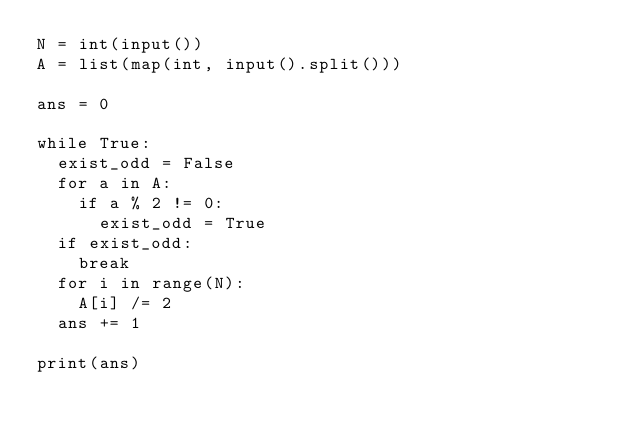Convert code to text. <code><loc_0><loc_0><loc_500><loc_500><_Python_>N = int(input())
A = list(map(int, input().split()))

ans = 0

while True:
  exist_odd = False
  for a in A:
    if a % 2 != 0:
      exist_odd = True
  if exist_odd:
    break
  for i in range(N):
    A[i] /= 2
  ans += 1
  
print(ans)
    </code> 